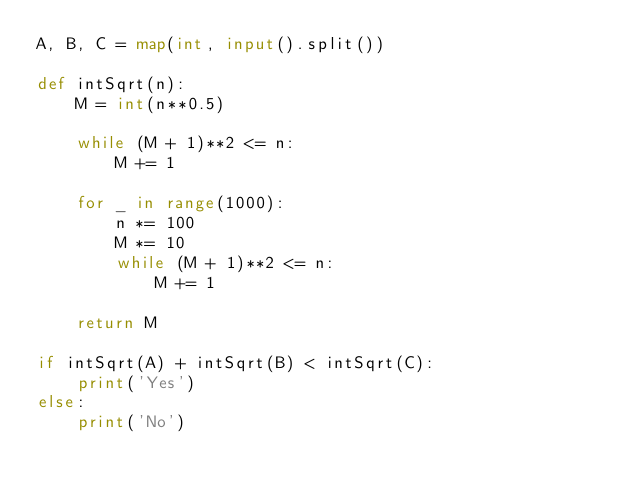<code> <loc_0><loc_0><loc_500><loc_500><_Python_>A, B, C = map(int, input().split())

def intSqrt(n):
    M = int(n**0.5)

    while (M + 1)**2 <= n:
        M += 1

    for _ in range(1000):
        n *= 100
        M *= 10
        while (M + 1)**2 <= n:
            M += 1

    return M

if intSqrt(A) + intSqrt(B) < intSqrt(C):
    print('Yes')
else:
    print('No')
</code> 